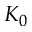Convert formula to latex. <formula><loc_0><loc_0><loc_500><loc_500>K _ { 0 }</formula> 